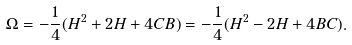Convert formula to latex. <formula><loc_0><loc_0><loc_500><loc_500>\Omega = - \frac { 1 } { 4 } ( H ^ { 2 } + 2 H + 4 C B ) = - \frac { 1 } { 4 } ( H ^ { 2 } - 2 H + 4 B C ) .</formula> 